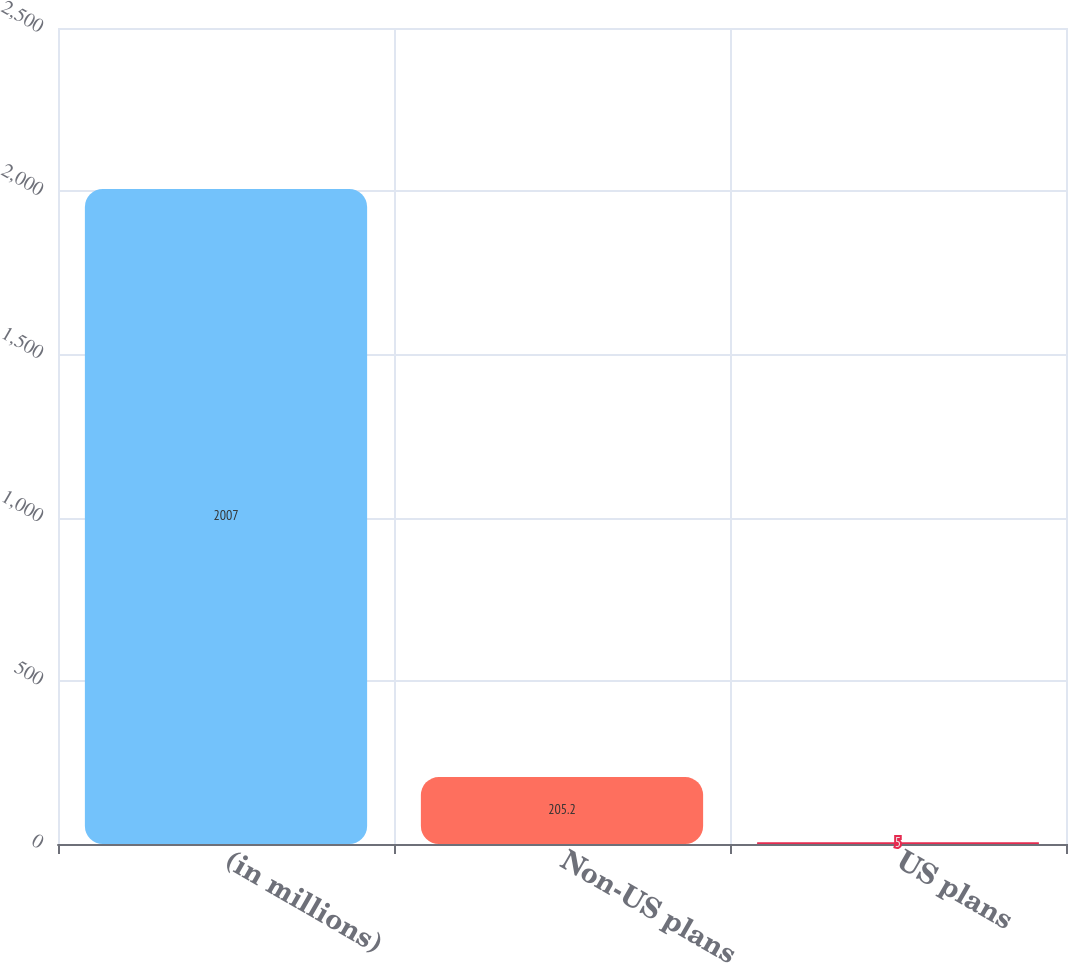<chart> <loc_0><loc_0><loc_500><loc_500><bar_chart><fcel>(in millions)<fcel>Non-US plans<fcel>US plans<nl><fcel>2007<fcel>205.2<fcel>5<nl></chart> 